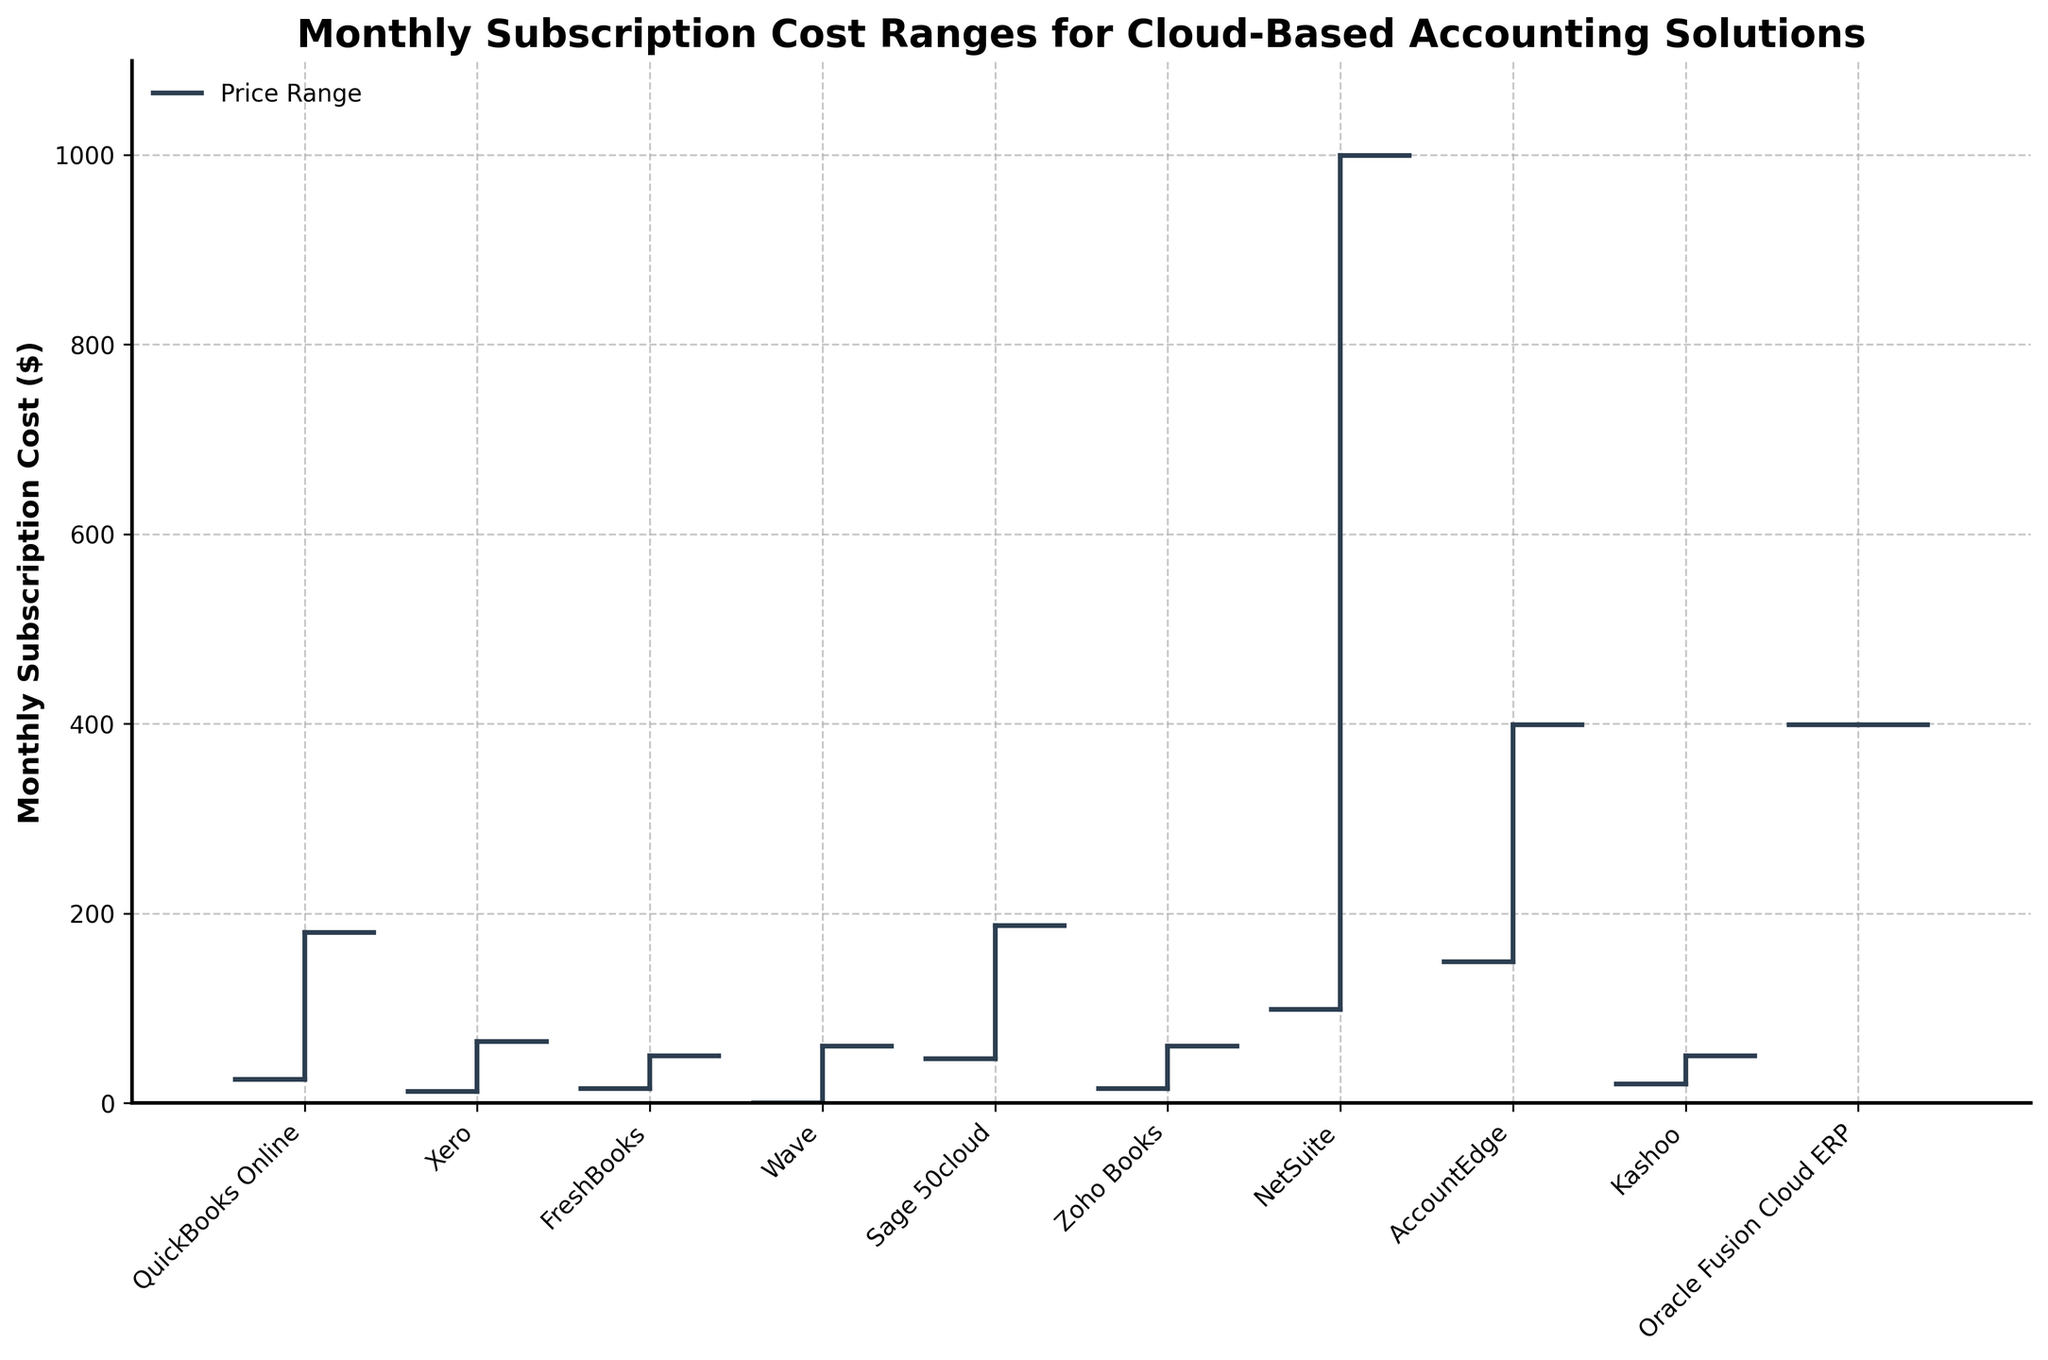What is the title of the plot? The title is located at the top of the plot and usually indicates the main theme or subject.
Answer: Monthly Subscription Cost Ranges for Cloud-Based Accounting Solutions What is the price range for QuickBooks Online? To find this, look at the vertical line and endpoints for QuickBooks Online; the line indicates the range from the lowest (bottom) to the highest (top) subscription cost.
Answer: $25 to $180 Which software has the lowest entry-level monthly subscription cost? Compare the starting points of each software on the leftmost side of the OHLC bars to determine the lowest value.
Answer: Wave ($0) What is the highest monthly subscription cost among all the software listed? Identify the longest vertical line in the plot and look at its upper endpoint to find the maximum subscription cost.
Answer: $999 (NetSuite) Which software offers the highest professional tier subscription? Locate the third value (professional tier) for each software and identify the maximum value.
Answer: NetSuite ($499) Which two software options have no data for the Enterprise tier? Find the software entries without a line extending to the Enterprise tier (fourth value).
Answer: Xero and FreshBooks What is the median of the highest subscription prices across all software? Sort the highest subscription prices from each software, then find the middle value to determine the median.
Answer: Median is $180 (Center value in the sorted list $60, $65, $80, $180, $187, $399, $499, $999) Which software has the widest subscription cost range? Compare the length of all vertical lines to find the one that spans the greatest distance from lowest to highest.
Answer: NetSuite ($0 to $999) How many subscription tiers does Kashoo offer? Count the number of data points (ticks) on the OHLC line for Kashoo.
Answer: Three tiers (Basic, Standard, Professional) Between QuickBooks Online and Sage 50cloud, which one offers a cheaper basic tier subscription? Compare the leftmost data points (open ticks) for QuickBooks Online and Sage 50cloud.
Answer: QuickBooks Online ($25) 